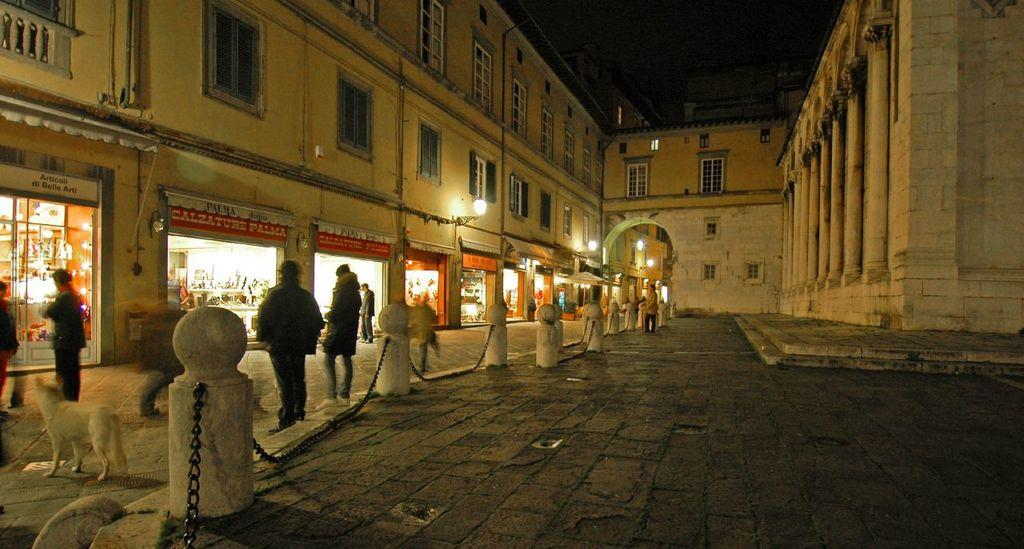<image>
Create a compact narrative representing the image presented. Several people standing outside a Calzature pizza store at nighttime 